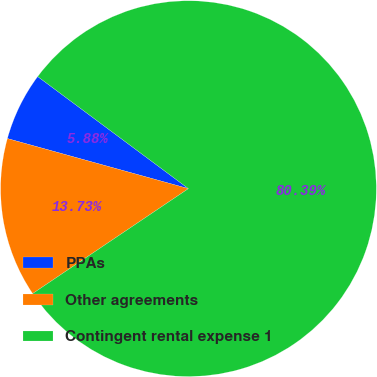Convert chart. <chart><loc_0><loc_0><loc_500><loc_500><pie_chart><fcel>PPAs<fcel>Other agreements<fcel>Contingent rental expense 1<nl><fcel>5.88%<fcel>13.73%<fcel>80.39%<nl></chart> 